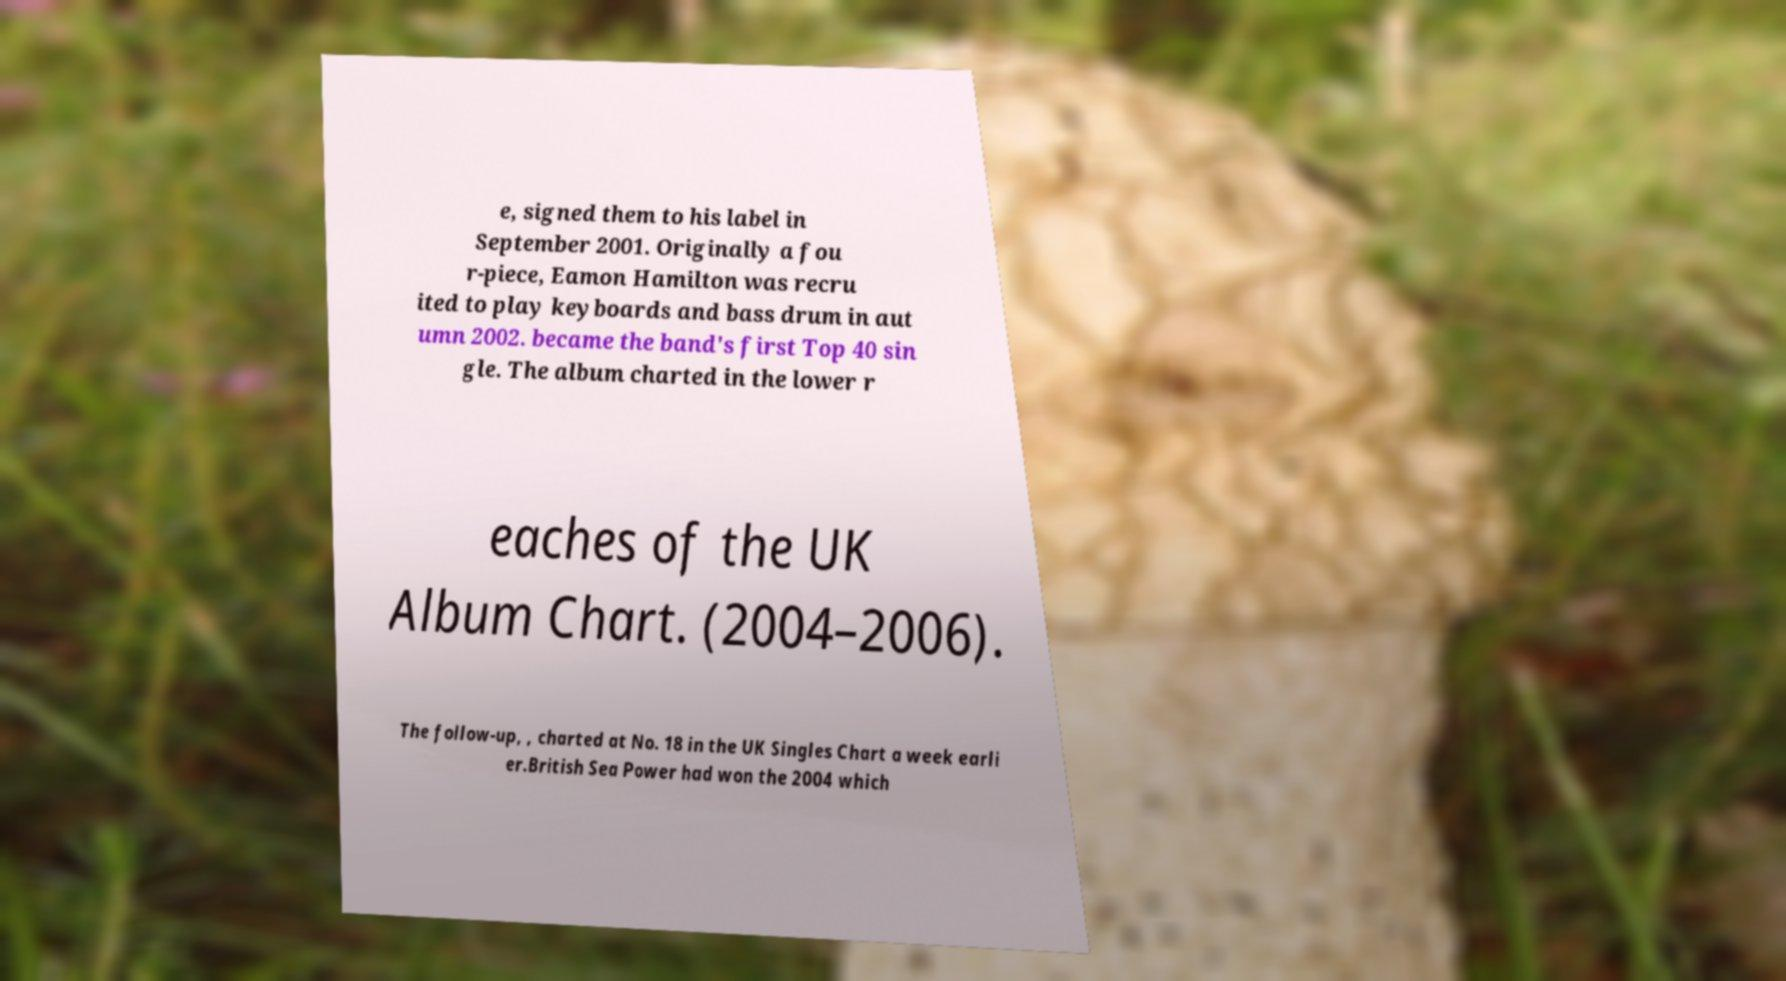I need the written content from this picture converted into text. Can you do that? e, signed them to his label in September 2001. Originally a fou r-piece, Eamon Hamilton was recru ited to play keyboards and bass drum in aut umn 2002. became the band's first Top 40 sin gle. The album charted in the lower r eaches of the UK Album Chart. (2004–2006). The follow-up, , charted at No. 18 in the UK Singles Chart a week earli er.British Sea Power had won the 2004 which 